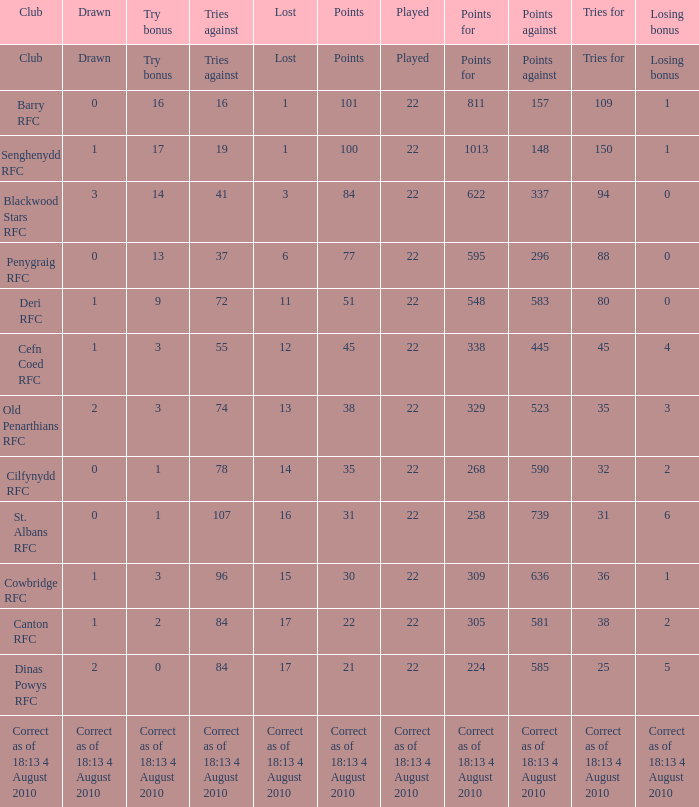What is the played number when tries against is 84, and drawn is 2? 22.0. 